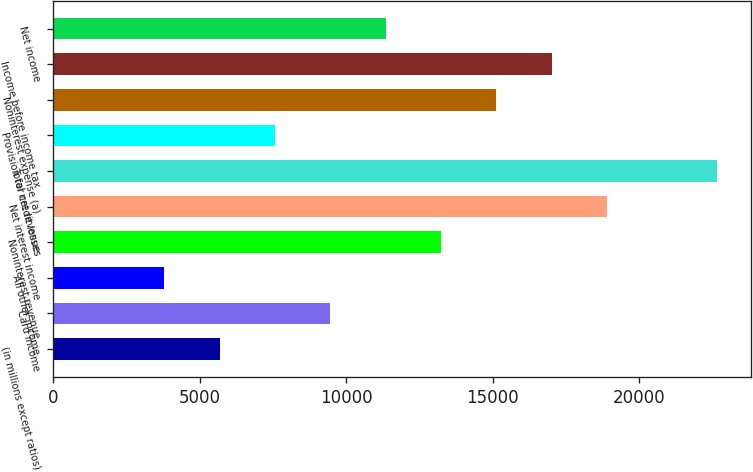Convert chart. <chart><loc_0><loc_0><loc_500><loc_500><bar_chart><fcel>(in millions except ratios)<fcel>Card income<fcel>All other income<fcel>Noninterest revenue<fcel>Net interest income<fcel>Total net revenue<fcel>Provision for credit losses<fcel>Noninterest expense (a)<fcel>Income before income tax<fcel>Net income<nl><fcel>5688.4<fcel>9460<fcel>3802.6<fcel>13231.6<fcel>18889<fcel>22660.6<fcel>7574.2<fcel>15117.4<fcel>17003.2<fcel>11345.8<nl></chart> 